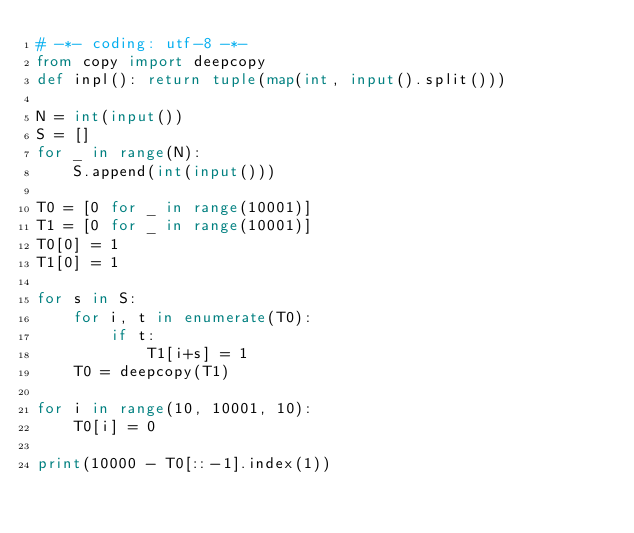Convert code to text. <code><loc_0><loc_0><loc_500><loc_500><_Python_># -*- coding: utf-8 -*-
from copy import deepcopy
def inpl(): return tuple(map(int, input().split()))

N = int(input())
S = []
for _ in range(N):
    S.append(int(input()))

T0 = [0 for _ in range(10001)]
T1 = [0 for _ in range(10001)]
T0[0] = 1
T1[0] = 1

for s in S:
    for i, t in enumerate(T0):
        if t:
            T1[i+s] = 1
    T0 = deepcopy(T1)

for i in range(10, 10001, 10):
    T0[i] = 0 

print(10000 - T0[::-1].index(1))</code> 